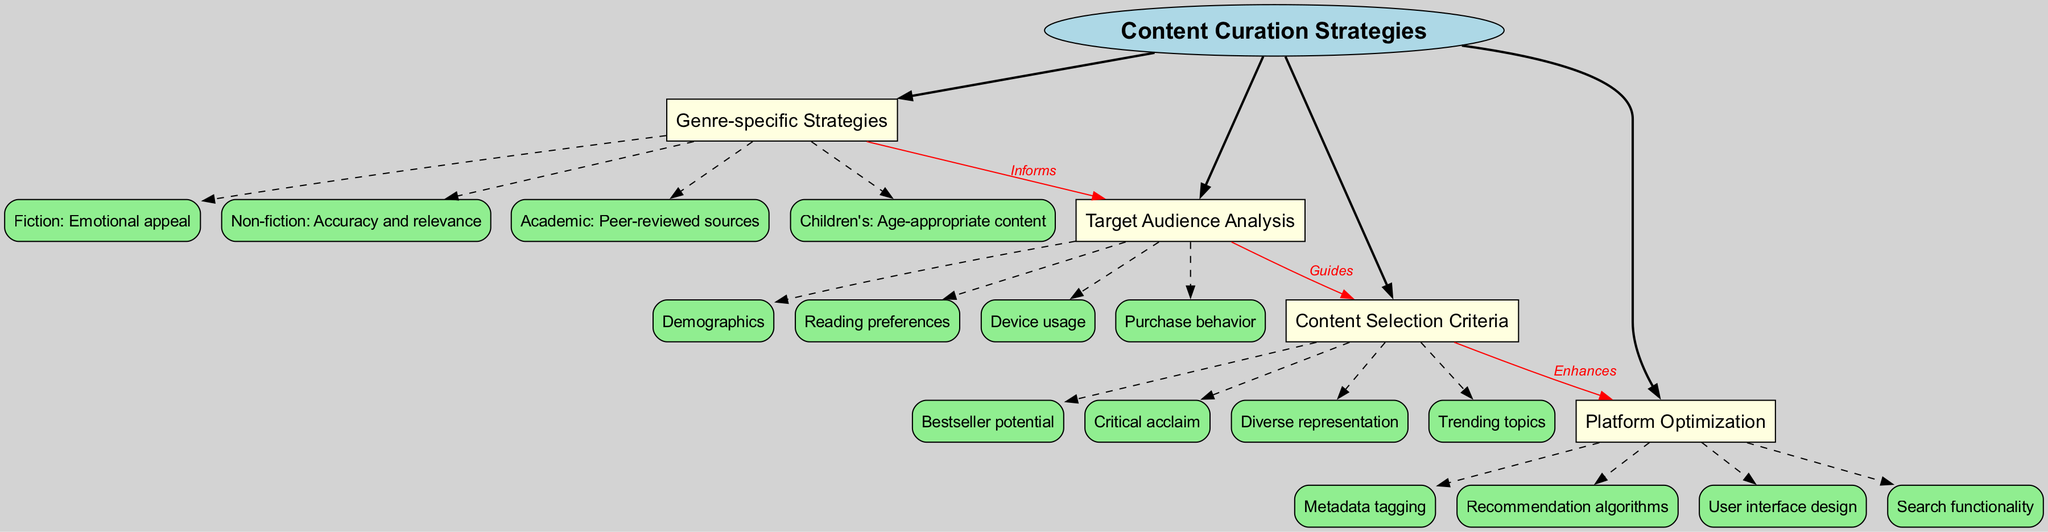What is the central concept of the diagram? The central concept is clearly labeled in the diagram as "Content Curation Strategies". This value is found in the center, indicated by its distinct shape and color.
Answer: Content Curation Strategies How many main branches does the diagram have? The diagram showcases four main branches extending from the central concept. Each branch can be counted visually, as there are distinct connections to the central concept.
Answer: 4 What is the label connecting "Genre-specific Strategies" and "Target Audience Analysis"? The diagram explicitly shows a red edge leading from "Genre-specific Strategies" to "Target Audience Analysis" with the label "Informs" attached. Thus, one can refer directly to the connection's label.
Answer: Informs Which sub-branch corresponds to academic strategies? Among the sub-branches under "Genre-specific Strategies", the label "Peer-reviewed sources" is directly related to academic strategies, and it can be identified visually.
Answer: Peer-reviewed sources How does "Target Audience Analysis" guide "Content Selection Criteria"? There is a direct relationship shown with a red labeled edge connecting "Target Audience Analysis" to "Content Selection Criteria", indicating that one guides the other. The diagram's structure shows the flow of guidance clearly.
Answer: Guides What strategy is aimed at children's content? The sub-branch specifically targeting children's content is "Age-appropriate content", which can be seen under the main branch "Genre-specific Strategies".
Answer: Age-appropriate content Which element enhances "Platform Optimization"? The diagram highlights a relationship where "Content Selection Criteria" enhances "Platform Optimization". This connection is indicated with a red labeled edge.
Answer: Enhances What are the device usage aspects considered in the content curation strategy? "Device usage" is a distinct sub-branch under "Target Audience Analysis". This value can be identified directly from the main branches in the diagram.
Answer: Device usage What does the color scheme represent in the concept map? The different colors in the map help distinguish between the central concept, main branches, and sub-branches, aiding in visual categorization and coherence. Each color maintains a consistent meaning throughout the diagram.
Answer: Color distinction 